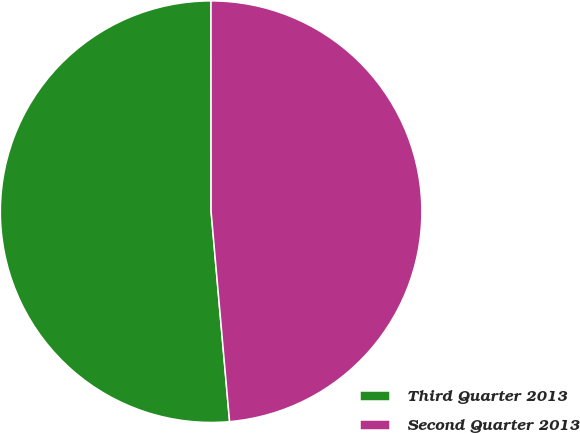Convert chart. <chart><loc_0><loc_0><loc_500><loc_500><pie_chart><fcel>Third Quarter 2013<fcel>Second Quarter 2013<nl><fcel>51.39%<fcel>48.61%<nl></chart> 